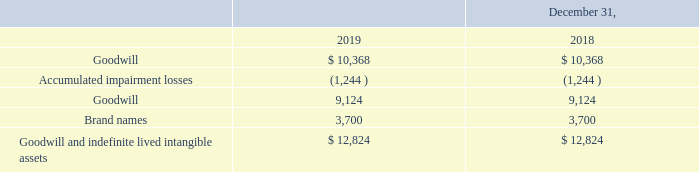Note 5 – Goodwill and Intangible Assets
Goodwill and indefinite-lived intangible assets consisted of the following:
Goodwill
The Company performed the annual impairment assessment of goodwill for our single reporting unit as of December 31, 2019, noting no impairment loss. The fair value exceeded the carrying value by 2.4%. Considerable management judgment is necessary to evaluate goodwill for impairment. We estimate fair value using widely accepted valuation techniques including discounted cash flows and market multiples analysis with respect to our single reporting unit. These valuation approaches are dependent upon a number of factors, including estimates of future growth rates, our cost of capital, capital expenditures, income tax rates, and other variables. Assumptions used in our valuations were consistent with our internal projections and operating plans. Our discounted cash flows forecast could be negatively impacted by a change in the competitive landscape, any internal decisions to pursue new or different strategies, a loss of a significant customer, or a significant change in the market place including changes in the prices paid for our products or changes in the size of the market for our products. Additionally, under the market approach analysis, we used significant other observable inputs including various guideline company comparisons. We base our fair value estimates on assumptions we believe to be reasonable, but which are unpredictable and inherently uncertain. Changes in these estimates or assumptions could materially affect the determination of fair value and the conclusions of the quantitative goodwill test for our one reporting unit.
Indefinite-lived Intangible Assets
The Company performed the annual impairment assessment on the indefinite-lived intangible asset as of December 31, 2019 and 2018, resulting in no impairment losses.
By how much did the fair value exceed the carrying value by? 2.4%. What does the company use to estimate fair value? Widely accepted valuation techniques including discounted cash flows and market multiples analysis with respect to our single reporting unit. What is the value of brand names as of December 31, 2019? 3,700. What is the change in the value of brand names between 2018 and 2019? 3,700-3,700
Answer: 0. What is the average goodwill and indefinite lived intangible assets for 2018 and 2019? (12,824+12,824)/2
Answer: 12824. What is the percentage constitution of brand names among the total goodwill and indefinite lived intangible assets in 2019?
Answer scale should be: percent. 3,700/12,824
Answer: 28.85. 